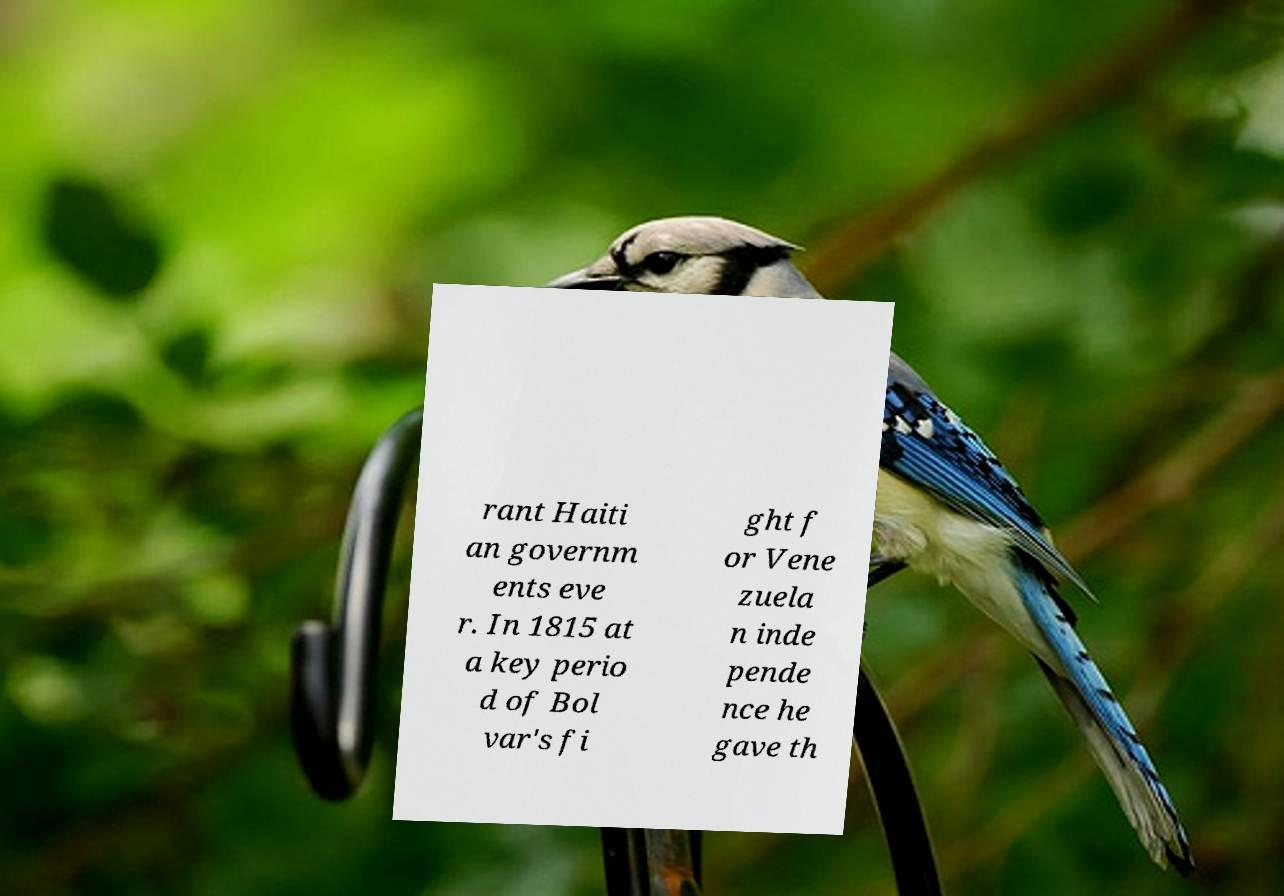I need the written content from this picture converted into text. Can you do that? rant Haiti an governm ents eve r. In 1815 at a key perio d of Bol var's fi ght f or Vene zuela n inde pende nce he gave th 